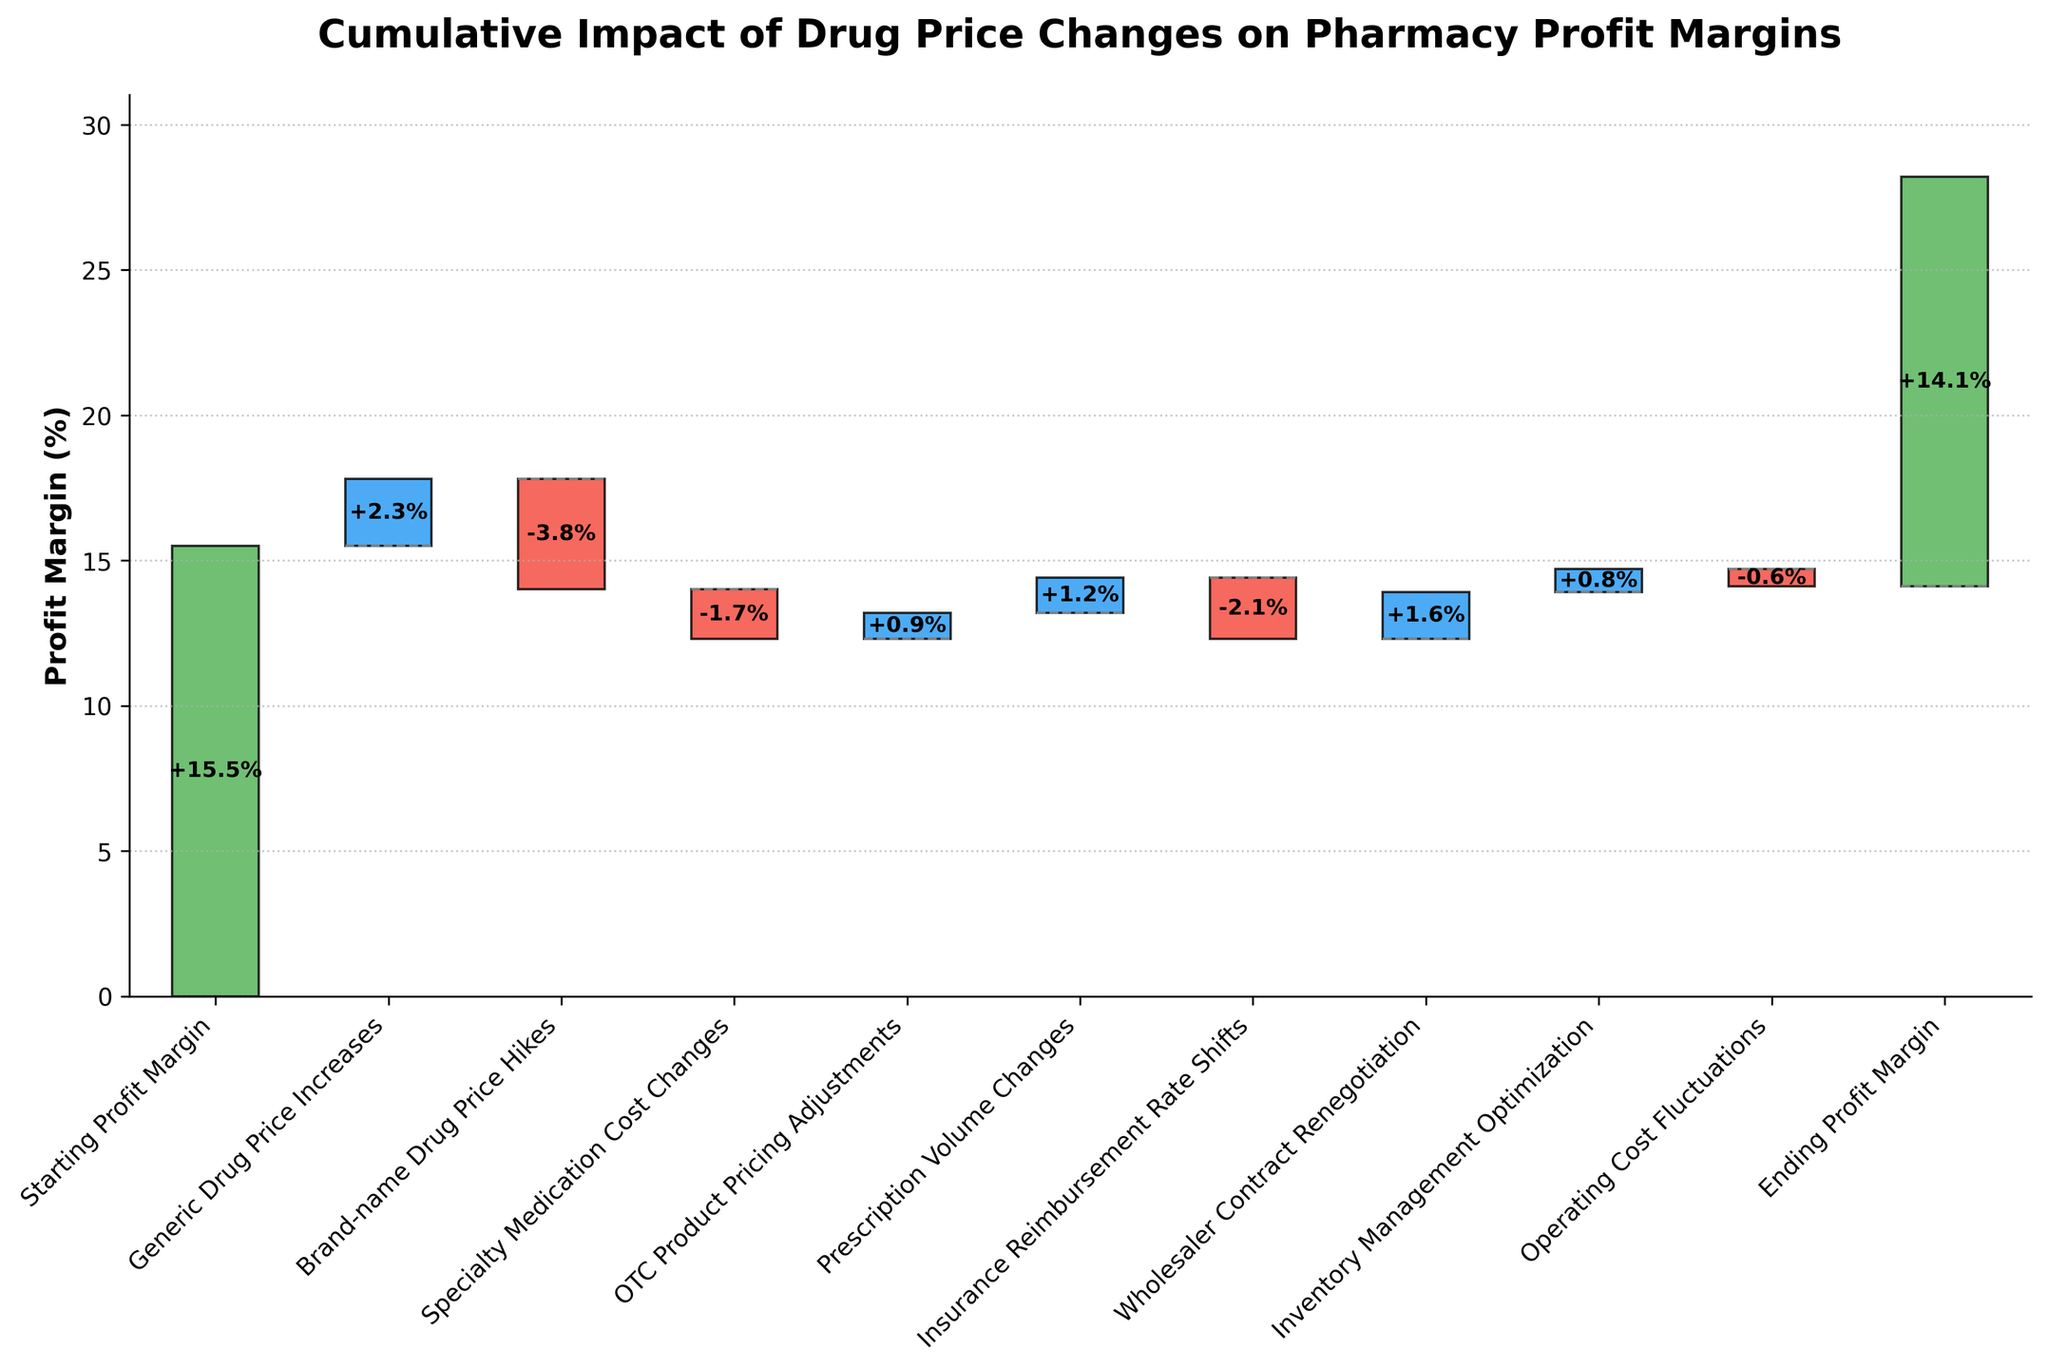What is the starting profit margin? The starting profit margin is shown as the first bar in the figure, labeled "Starting Profit Margin." Its value is clearly marked.
Answer: 15.5% Which category had the most negative impact on the profit margin? By observing the red bars (indicating negative impacts), we see that "Brand-name Drug Price Hikes" had the largest downward shift.
Answer: Brand-name Drug Price Hikes How did the generic drug price increases affect the profit margin? The bar for "Generic Drug Price Increases" is blue, indicating a positive change. The label shows a value of +2.3%.
Answer: +2.3% What was the final profit margin at the end of the fiscal year? The final profit margin is shown as the last bar on the chart, labeled "Ending Profit Margin." Its value is clearly labeled on the bar.
Answer: 14.1% How many categories contributed positively to the profit margin? By counting the blue bars (indicating positive changes), we identify four categories: "Generic Drug Price Increases," "OTC Product Pricing Adjustments," "Prescription Volume Changes," and "Inventory Management Optimization."
Answer: 4 What is the net impact of the brand-name drug price hikes and the specialty medication cost changes combined? Both are negative impacts. Adding the values, we get: -3.8% (Brand-name Drug Price Hikes) + -1.7% (Specialty Medication Cost Changes) = -5.5%.
Answer: -5.5% Compare the impact of insurance reimbursement rate shifts and wholesaler contract renegotiation. Which had a greater absolute impact? Insurance Reimbursement Rate Shifts had a -2.1% impact, and Wholesaler Contract Renegotiation had a +1.6% impact. In absolute terms, -2.1% is greater than +1.6%.
Answer: Insurance Reimbursement Rate Shifts What is the cumulative impact of all the changes before the final adjustment? By summing all contributions: 2.3 - 3.8 - 1.7 + 0.9 + 1.2 - 2.1 + 1.6 + 0.8 - 0.6 = -1.4%. Adding to the starting profit of 15.5%, we get 14.1%.
Answer: 14.1% Which made a larger positive impact: the prescription volume changes or the OTC product pricing adjustments? The bar for "Prescription Volume Changes" shows +1.2%, while "OTC Product Pricing Adjustments" shows +0.9%. Comparing the two, 1.2% is larger.
Answer: Prescription Volume Changes What is the combined impact of positive contributions on the profit margin? Adding the values of the positive contributions: 2.3% (Generic Drug Price Increases) + 0.9% (OTC Product Pricing Adjustments) + 1.2% (Prescription Volume Changes) + 1.6% (Wholesaler Contract Renegotiation) + 0.8% (Inventory Management Optimization) = 6.8%.
Answer: 6.8% 